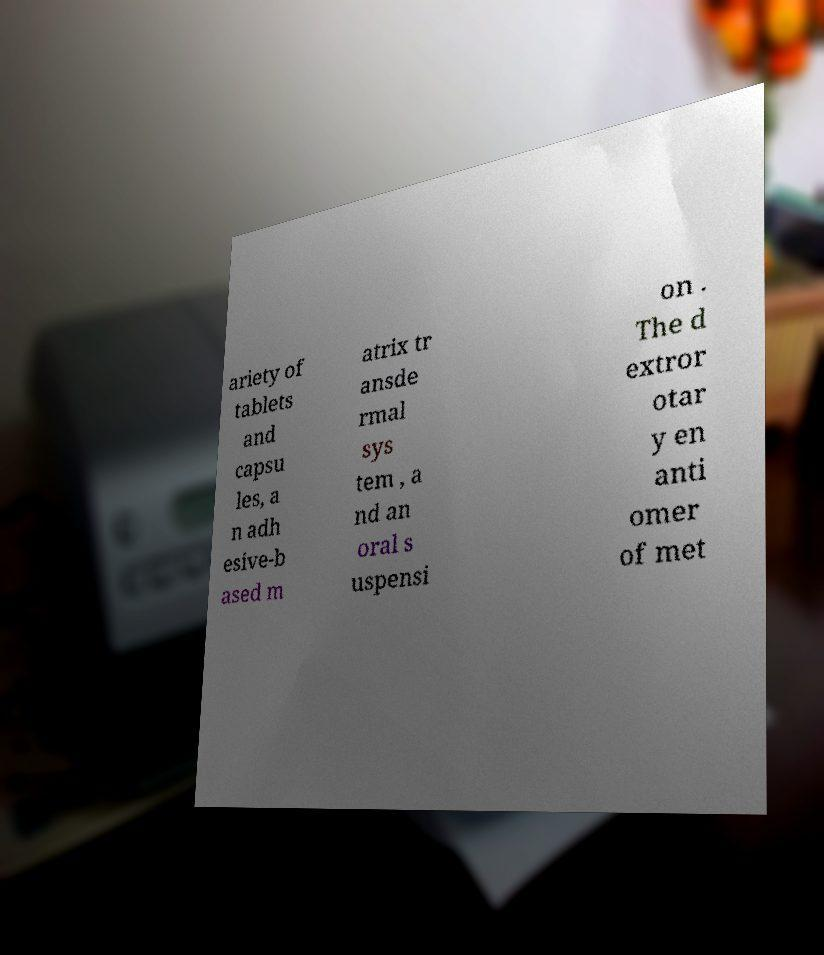Could you extract and type out the text from this image? ariety of tablets and capsu les, a n adh esive-b ased m atrix tr ansde rmal sys tem , a nd an oral s uspensi on . The d extror otar y en anti omer of met 